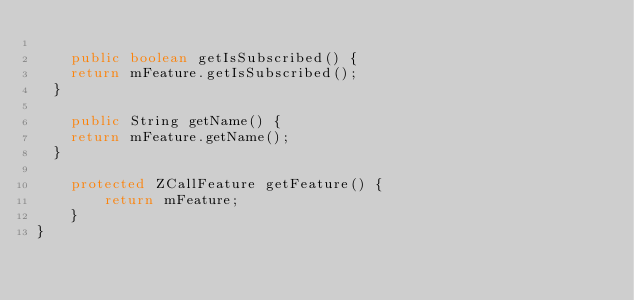Convert code to text. <code><loc_0><loc_0><loc_500><loc_500><_Java_>
    public boolean getIsSubscribed() {
		return mFeature.getIsSubscribed();
	}

    public String getName() {
		return mFeature.getName();
	}

    protected ZCallFeature getFeature() {
        return mFeature;
    }
}
</code> 